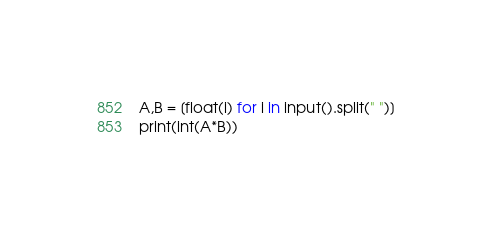Convert code to text. <code><loc_0><loc_0><loc_500><loc_500><_Python_>A,B = [float(i) for i in input().split(" ")]
print(int(A*B))</code> 